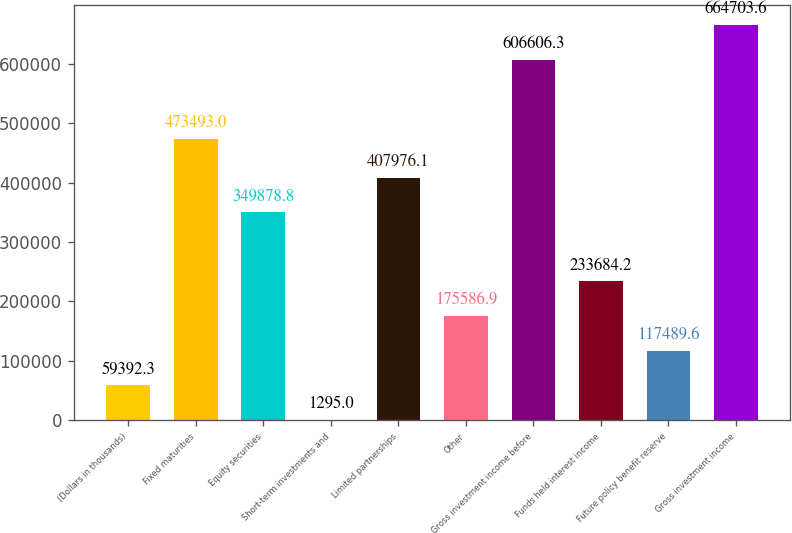Convert chart. <chart><loc_0><loc_0><loc_500><loc_500><bar_chart><fcel>(Dollars in thousands)<fcel>Fixed maturities<fcel>Equity securities<fcel>Short-term investments and<fcel>Limited partnerships<fcel>Other<fcel>Gross investment income before<fcel>Funds held interest income<fcel>Future policy benefit reserve<fcel>Gross investment income<nl><fcel>59392.3<fcel>473493<fcel>349879<fcel>1295<fcel>407976<fcel>175587<fcel>606606<fcel>233684<fcel>117490<fcel>664704<nl></chart> 